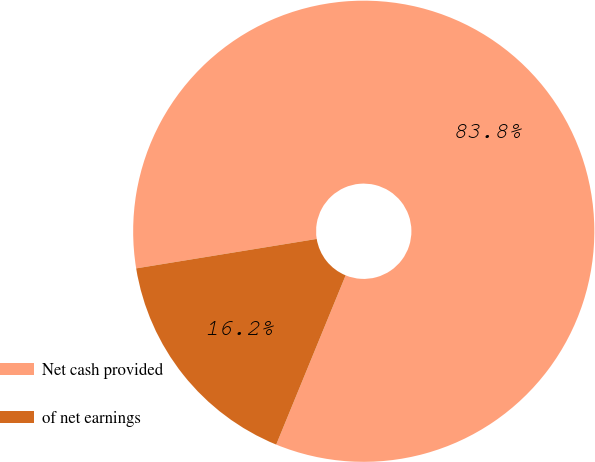<chart> <loc_0><loc_0><loc_500><loc_500><pie_chart><fcel>Net cash provided<fcel>of net earnings<nl><fcel>83.77%<fcel>16.23%<nl></chart> 